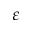Convert formula to latex. <formula><loc_0><loc_0><loc_500><loc_500>\varepsilon</formula> 